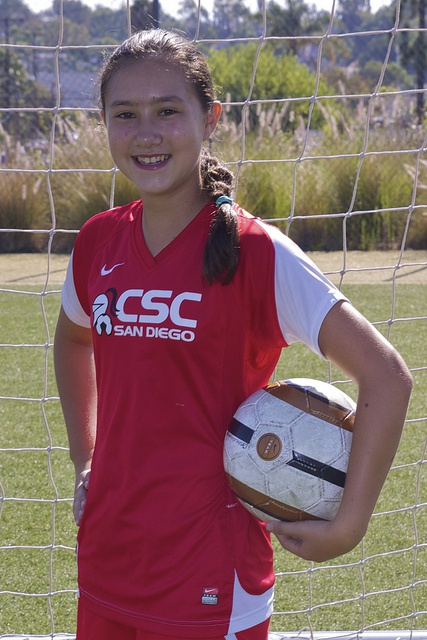Describe the objects in this image and their specific colors. I can see people in gray, maroon, and darkgray tones and sports ball in gray, darkgray, and maroon tones in this image. 